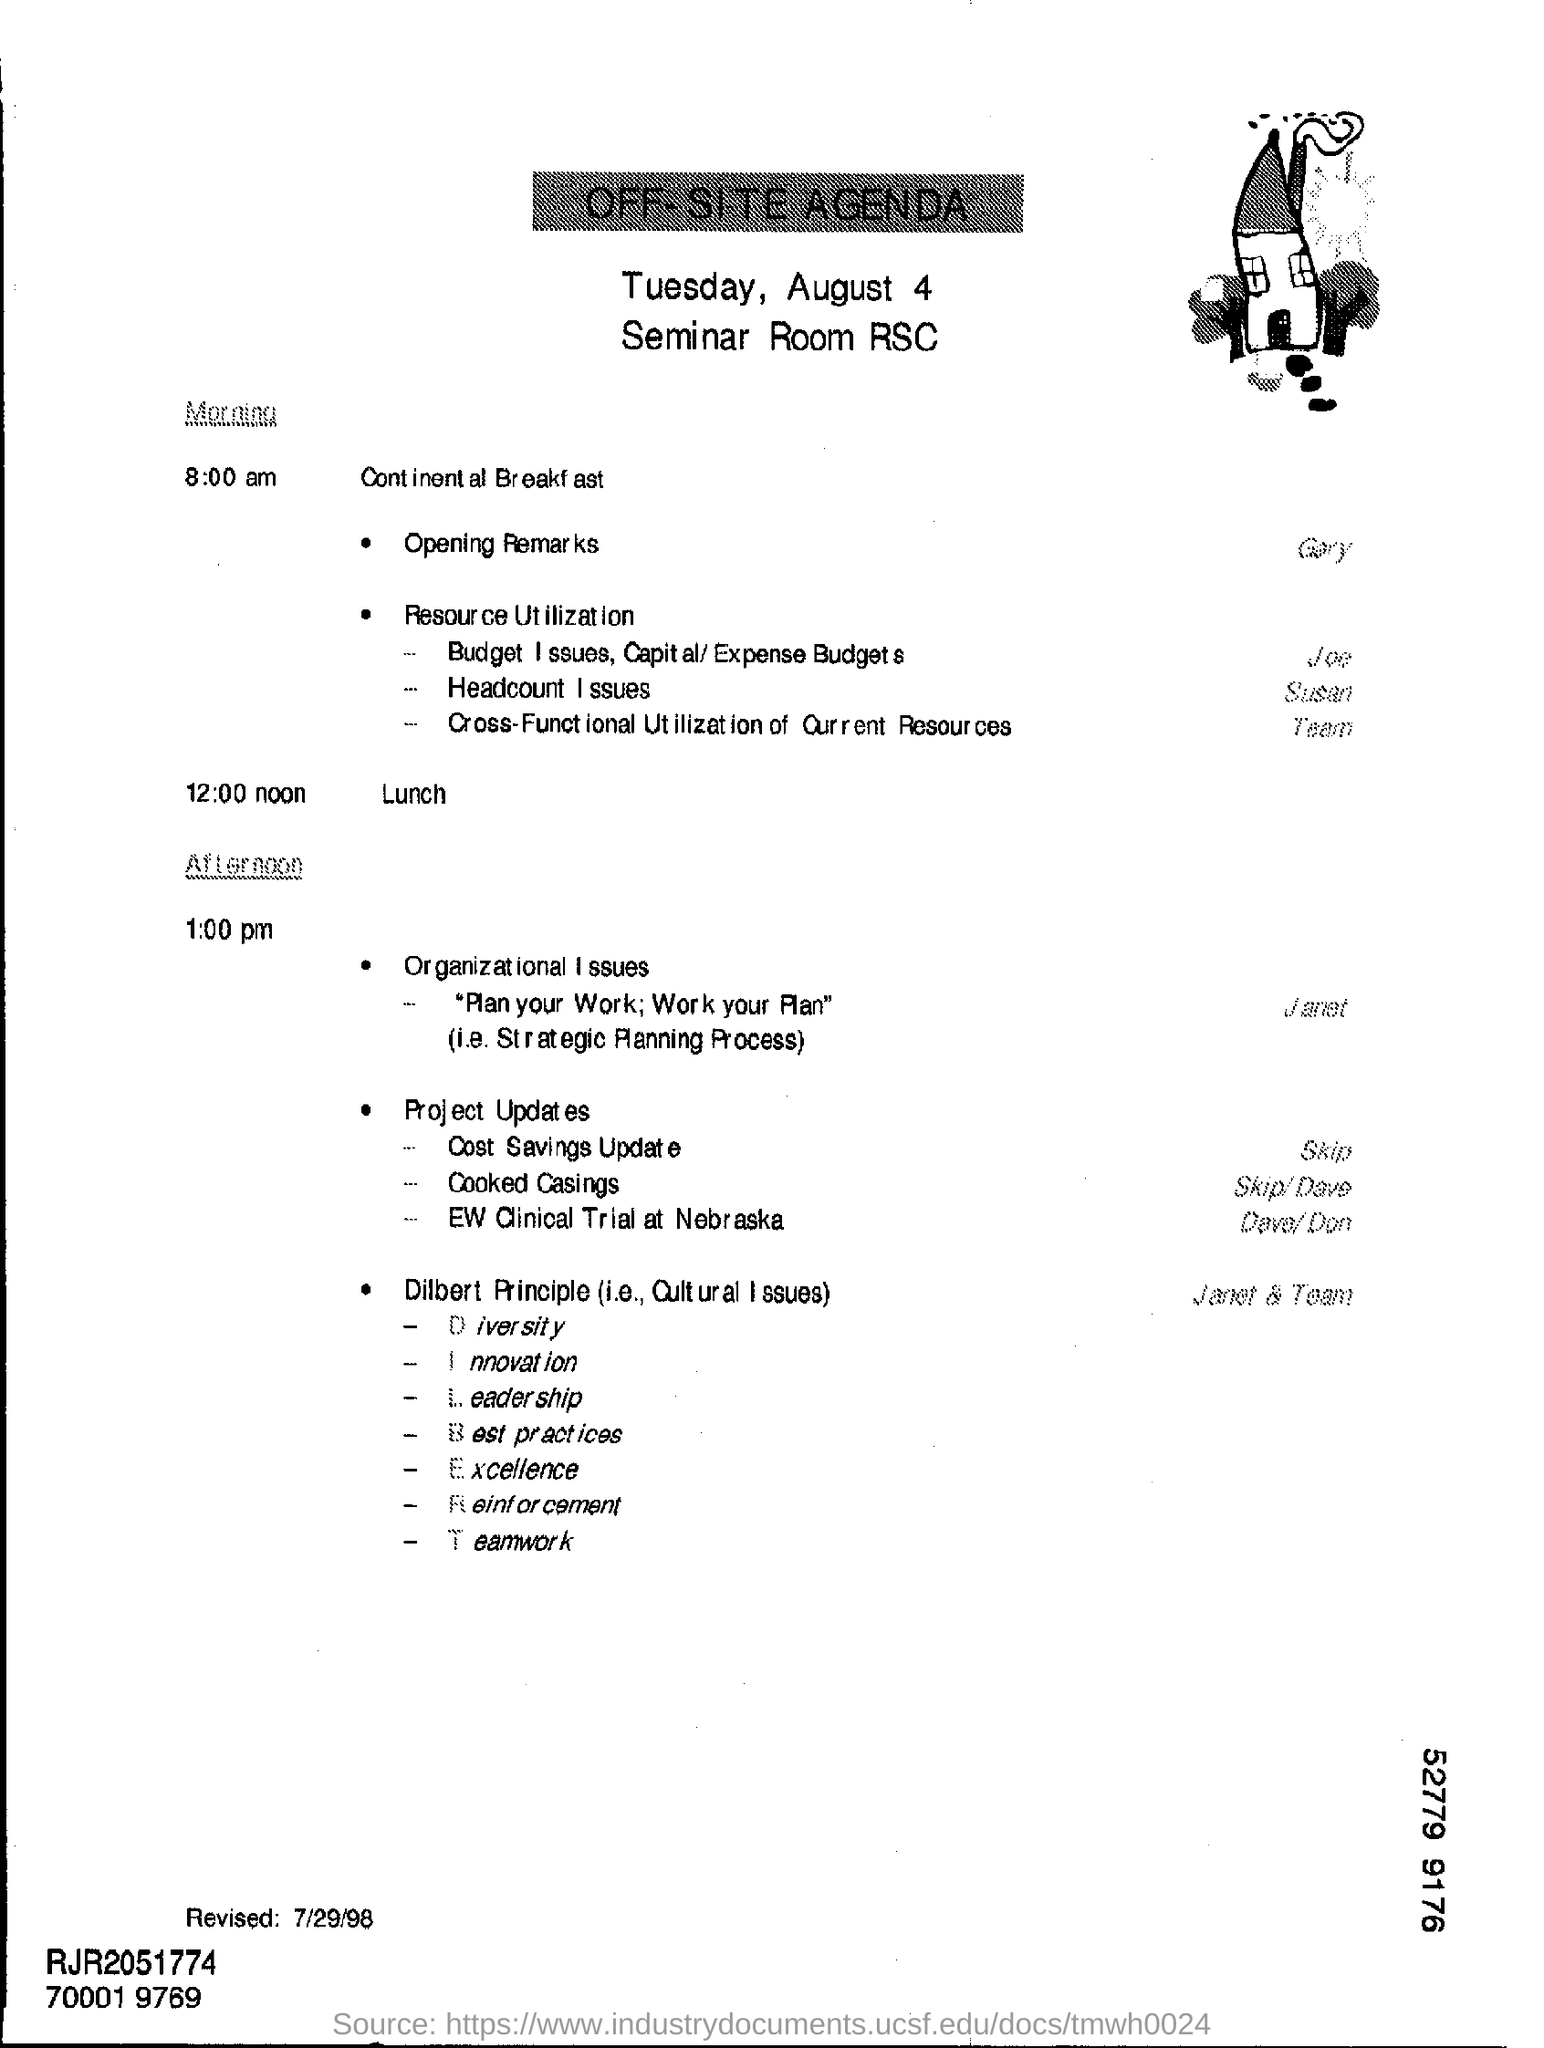What is the date mentioned in the top of the document ?
Make the answer very short. Tuesday, August 4. What is the Lunch Time ?
Provide a short and direct response. 12:00 noon. What is the Revised date?
Provide a short and direct response. 7/29/98. 